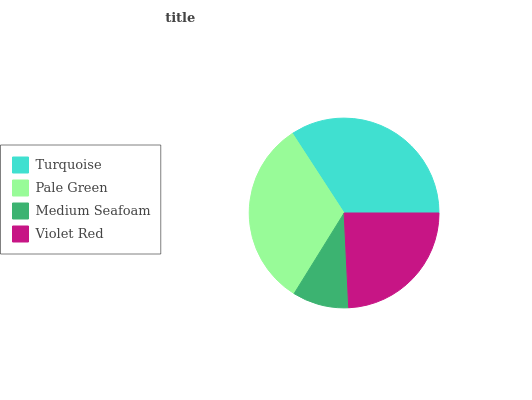Is Medium Seafoam the minimum?
Answer yes or no. Yes. Is Turquoise the maximum?
Answer yes or no. Yes. Is Pale Green the minimum?
Answer yes or no. No. Is Pale Green the maximum?
Answer yes or no. No. Is Turquoise greater than Pale Green?
Answer yes or no. Yes. Is Pale Green less than Turquoise?
Answer yes or no. Yes. Is Pale Green greater than Turquoise?
Answer yes or no. No. Is Turquoise less than Pale Green?
Answer yes or no. No. Is Pale Green the high median?
Answer yes or no. Yes. Is Violet Red the low median?
Answer yes or no. Yes. Is Violet Red the high median?
Answer yes or no. No. Is Pale Green the low median?
Answer yes or no. No. 